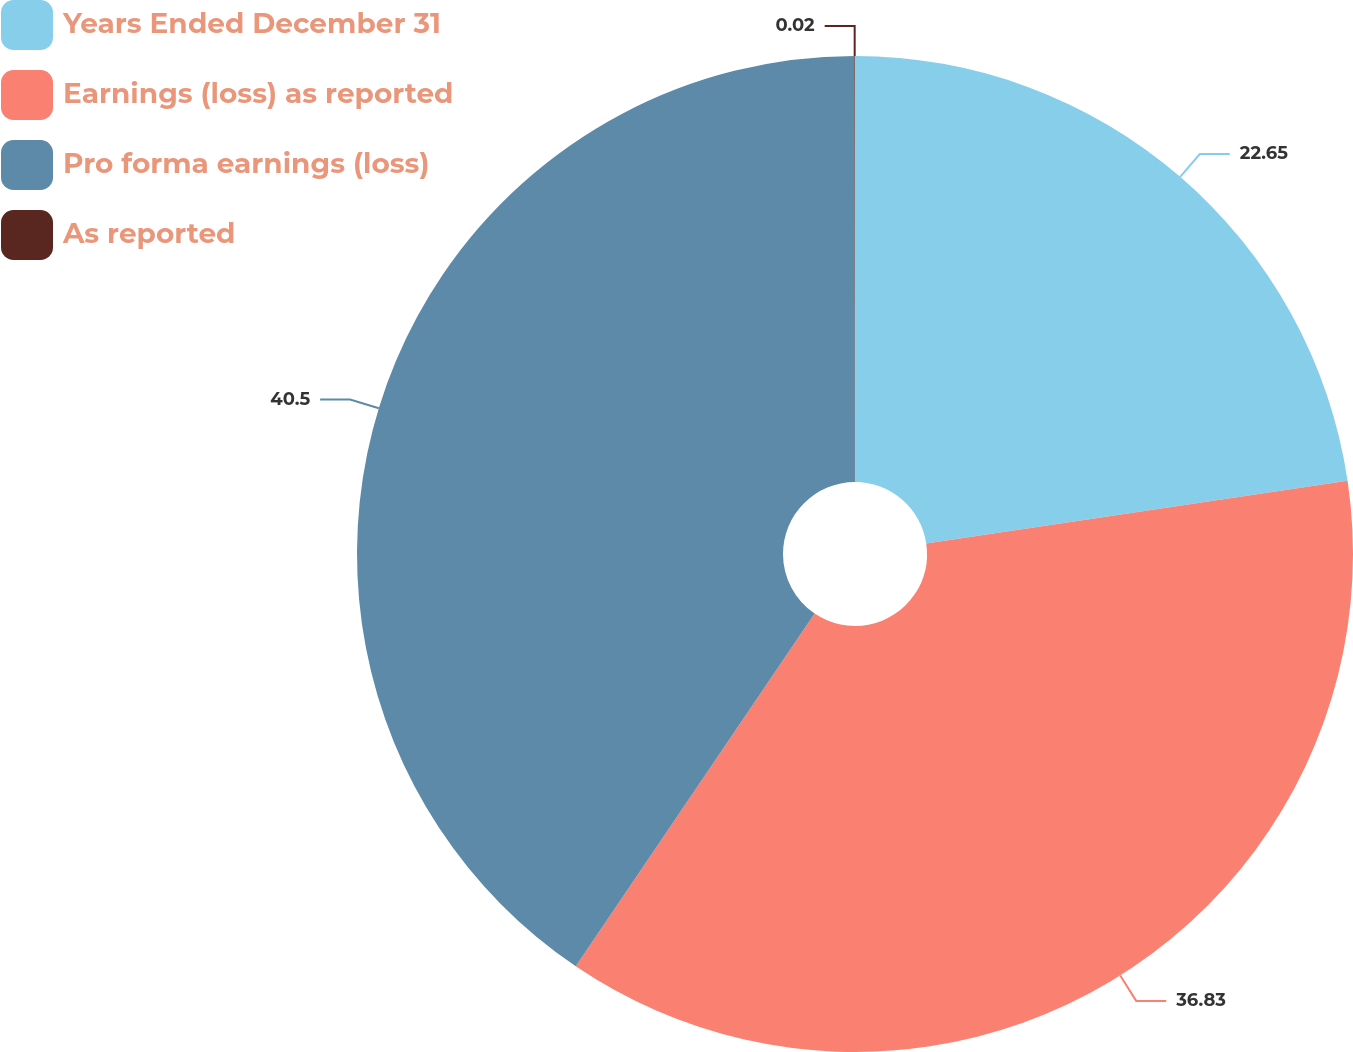<chart> <loc_0><loc_0><loc_500><loc_500><pie_chart><fcel>Years Ended December 31<fcel>Earnings (loss) as reported<fcel>Pro forma earnings (loss)<fcel>As reported<nl><fcel>22.65%<fcel>36.83%<fcel>40.51%<fcel>0.02%<nl></chart> 